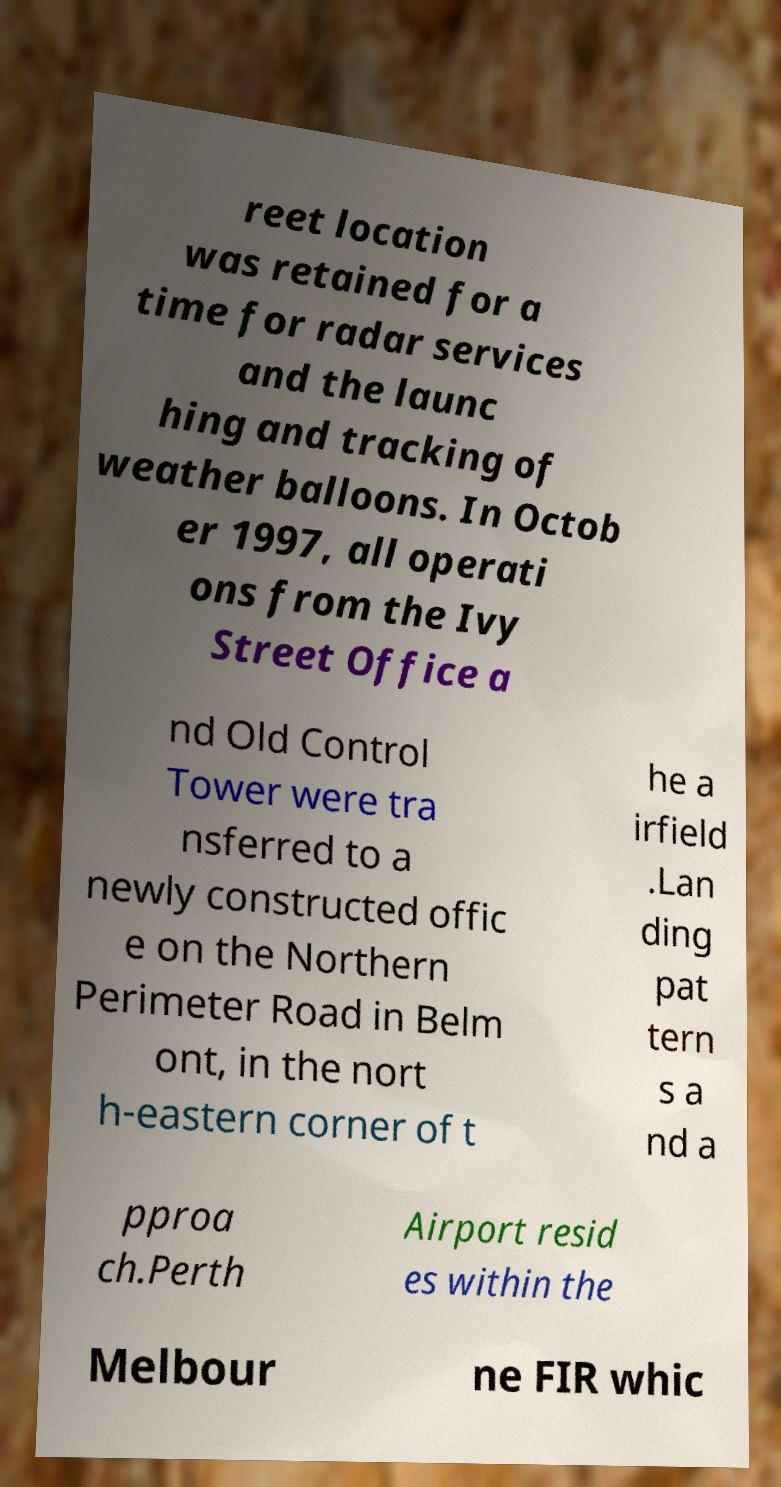Please identify and transcribe the text found in this image. reet location was retained for a time for radar services and the launc hing and tracking of weather balloons. In Octob er 1997, all operati ons from the Ivy Street Office a nd Old Control Tower were tra nsferred to a newly constructed offic e on the Northern Perimeter Road in Belm ont, in the nort h-eastern corner of t he a irfield .Lan ding pat tern s a nd a pproa ch.Perth Airport resid es within the Melbour ne FIR whic 